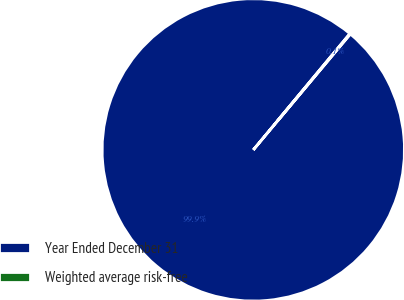Convert chart. <chart><loc_0><loc_0><loc_500><loc_500><pie_chart><fcel>Year Ended December 31<fcel>Weighted average risk-free<nl><fcel>99.93%<fcel>0.07%<nl></chart> 